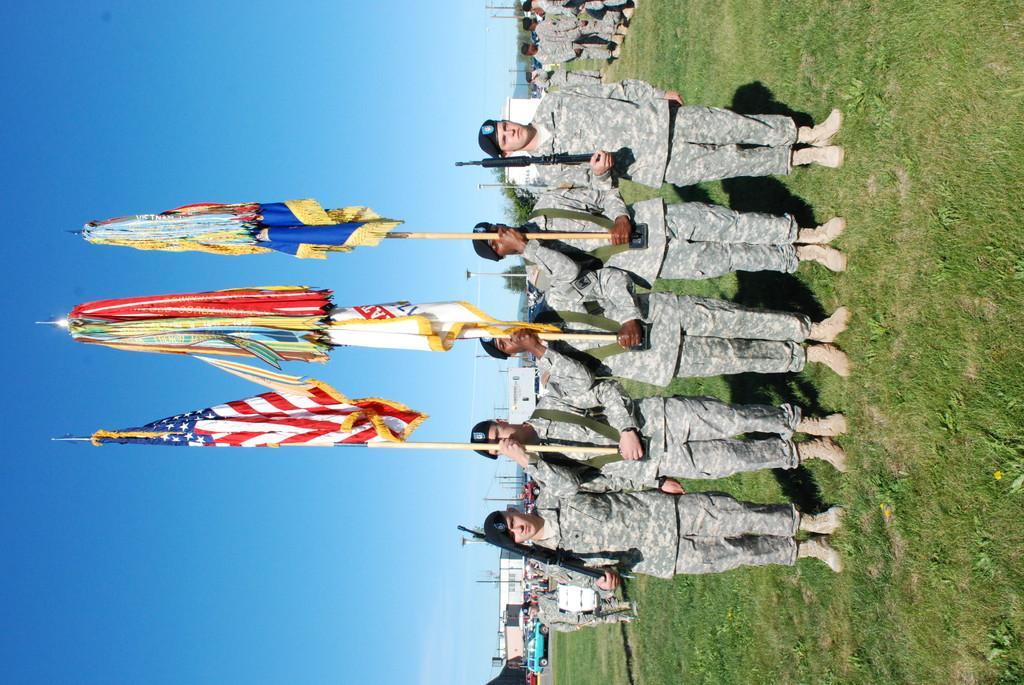How would you summarize this image in a sentence or two? In this image we can see group of persons wearing uniforms and caps. Three persons are holding poles containing flags. Two persons are holding guns in their hands. In the background, we can see group of vehicles, buildings and the sky. 